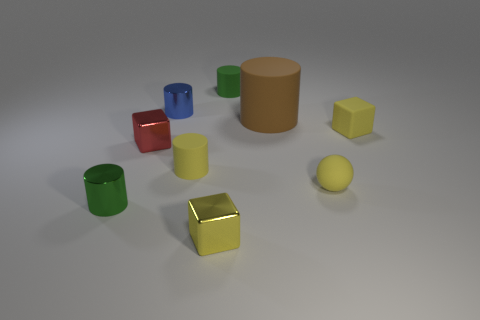The cube that is behind the small yellow metallic object and left of the large rubber object is what color?
Offer a very short reply. Red. How many other things are the same shape as the big brown matte thing?
Offer a very short reply. 4. There is a matte cube that is the same size as the yellow sphere; what is its color?
Offer a very short reply. Yellow. What color is the small object right of the small ball?
Keep it short and to the point. Yellow. Is there a tiny red shiny block that is right of the tiny block that is in front of the green shiny cylinder?
Provide a short and direct response. No. There is a blue object; is it the same shape as the small green thing that is in front of the big brown cylinder?
Your response must be concise. Yes. There is a object that is in front of the yellow matte sphere and right of the tiny green metal cylinder; what size is it?
Your response must be concise. Small. Are there any cyan objects made of the same material as the sphere?
Keep it short and to the point. No. There is a shiny thing that is the same color as the small ball; what size is it?
Your response must be concise. Small. What is the material of the tiny block that is left of the tiny yellow thing that is in front of the green metal object?
Your answer should be compact. Metal. 